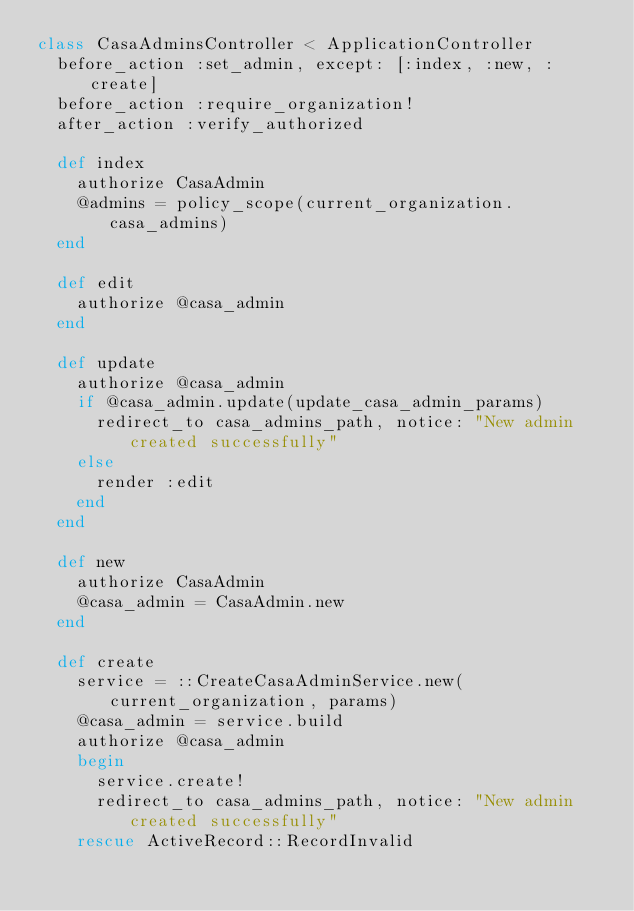Convert code to text. <code><loc_0><loc_0><loc_500><loc_500><_Ruby_>class CasaAdminsController < ApplicationController
  before_action :set_admin, except: [:index, :new, :create]
  before_action :require_organization!
  after_action :verify_authorized

  def index
    authorize CasaAdmin
    @admins = policy_scope(current_organization.casa_admins)
  end

  def edit
    authorize @casa_admin
  end

  def update
    authorize @casa_admin
    if @casa_admin.update(update_casa_admin_params)
      redirect_to casa_admins_path, notice: "New admin created successfully"
    else
      render :edit
    end
  end

  def new
    authorize CasaAdmin
    @casa_admin = CasaAdmin.new
  end

  def create
    service = ::CreateCasaAdminService.new(current_organization, params)
    @casa_admin = service.build
    authorize @casa_admin
    begin
      service.create!
      redirect_to casa_admins_path, notice: "New admin created successfully"
    rescue ActiveRecord::RecordInvalid</code> 